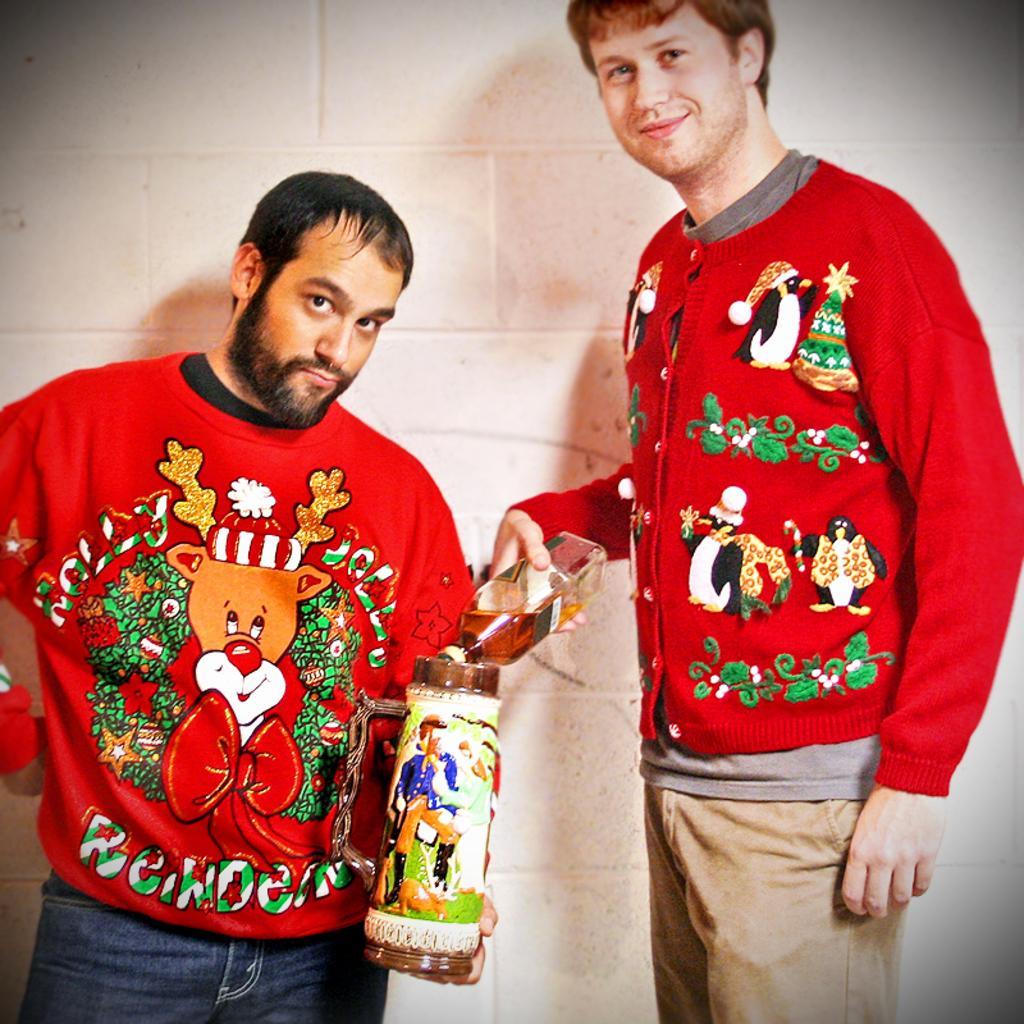Can you describe this image briefly? In this picture we can see two persons, one persons is holding a bottle, another person is holding a tin. 